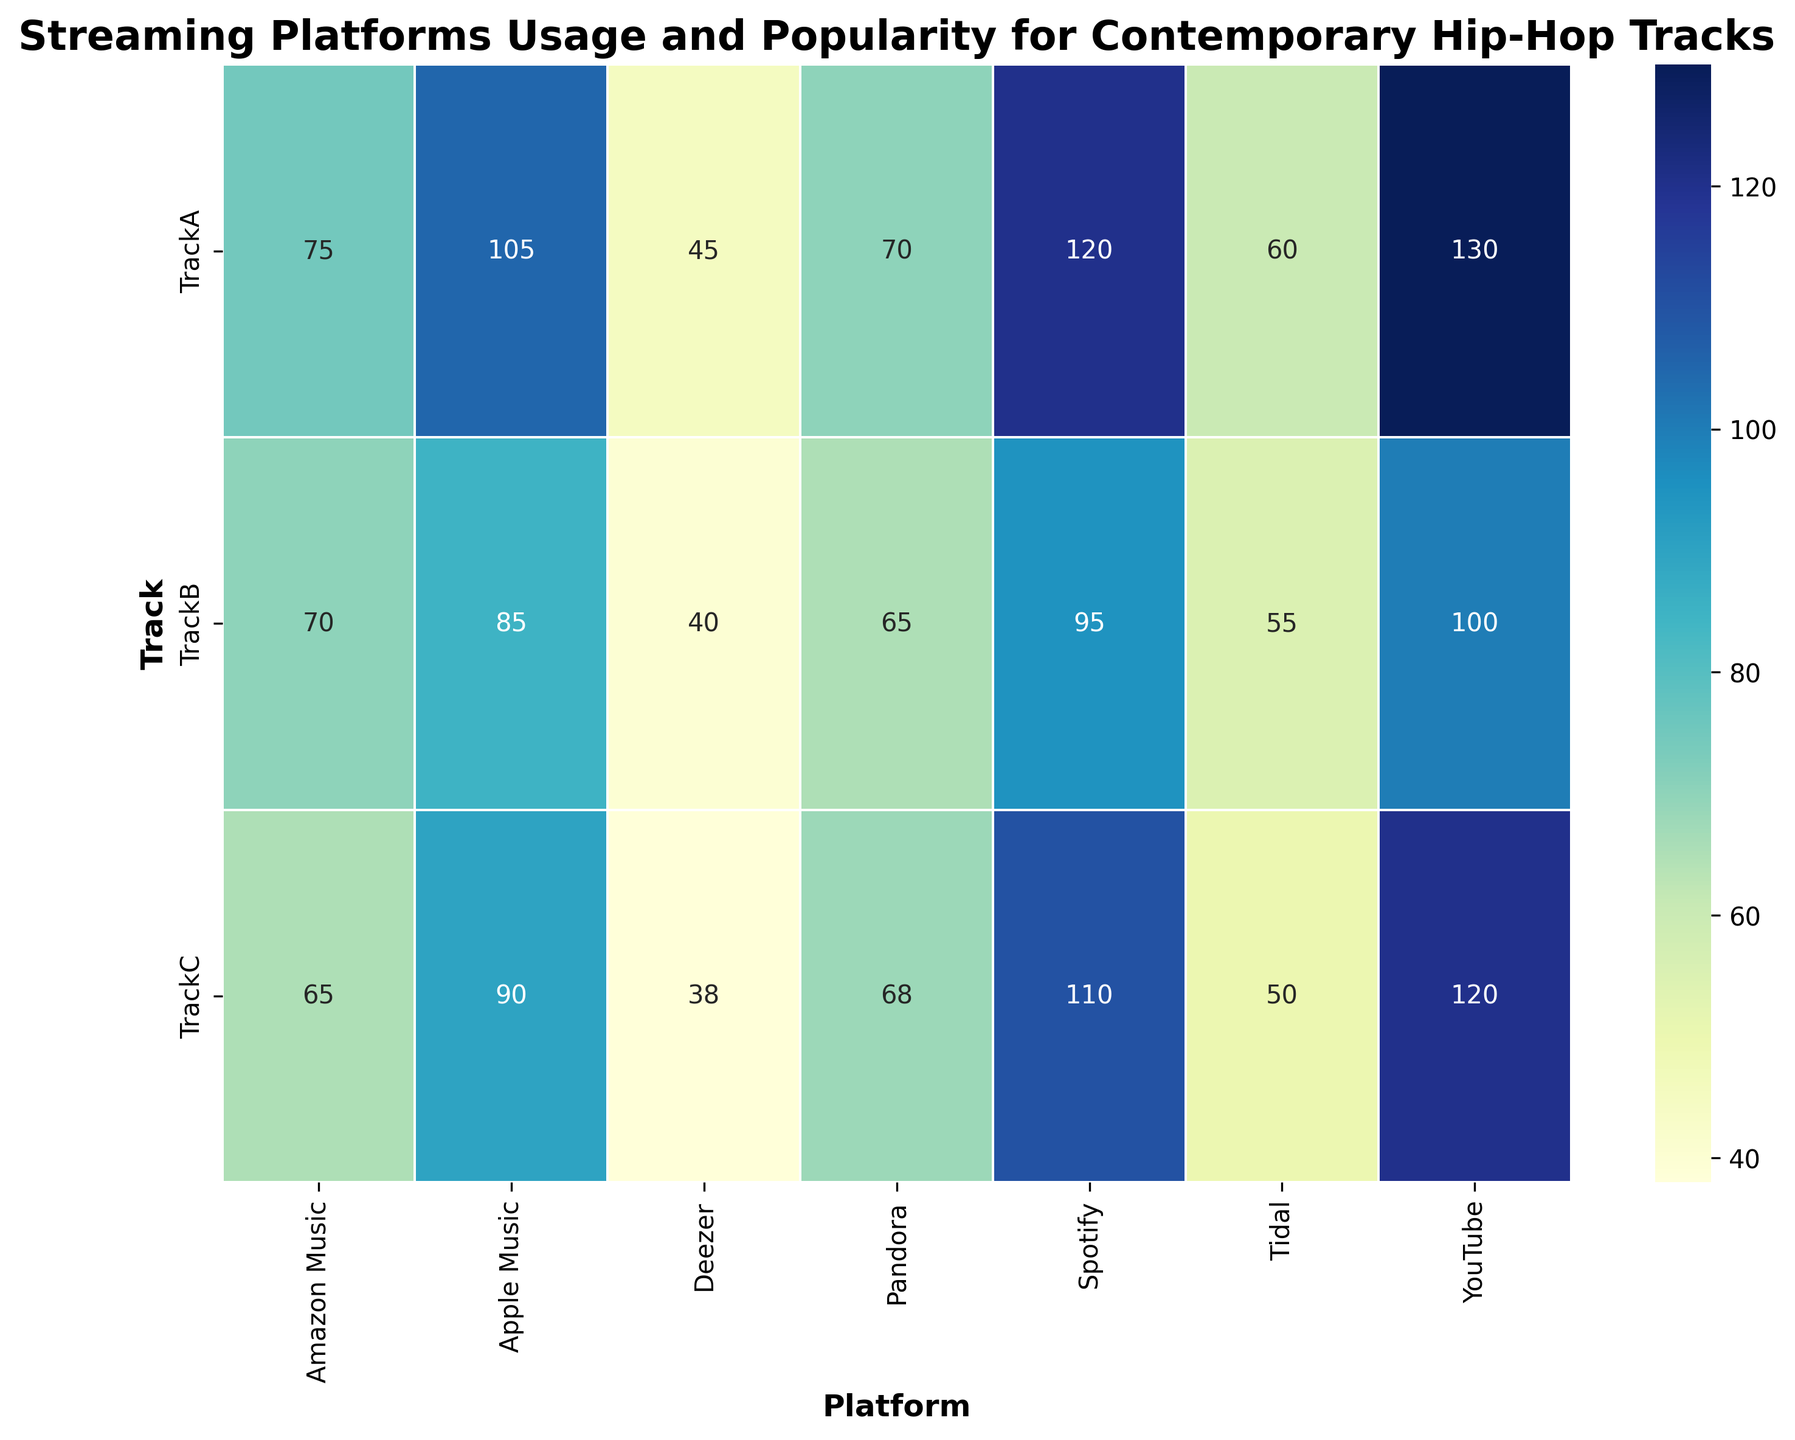What's the total number of streams for Track A across all platforms? Look at the values corresponding to Track A for each platform and sum them up: Spotify (120) + Apple Music (105) + YouTube (130) + Amazon Music (75) + Tidal (60) + Deezer (45) + Pandora (70) = 605
Answer: 605 Which platform has the highest number of streams for Track B? Compare the values for Track B across all platforms: Spotify (95), Apple Music (85), YouTube (100), Amazon Music (70), Tidal (55), Deezer (40), Pandora (65). YouTube has the highest streams.
Answer: YouTube Which track has the lowest number of streams on Tidal? Checking the streams on Tidal: Track A (60), Track B (55), Track C (50). Track C has the lowest number of streams.
Answer: Track C Which platform demonstrates the greatest variation in streaming numbers between the highest and lowest streamed tracks? Calculate the difference between the highest and lowest values for each platform: 
Spotify (120-95=25), Apple Music (105-85=20), YouTube (130-100=30), Amazon Music (75-65=10), Tidal (60-50=10), Deezer (45-38=7), Pandora (70-65=5). YouTube shows the highest variation, which is 130 - 100 = 30.
Answer: YouTube What's the average number of streams for Track C across all platforms? Sum the streams for Track C across all platforms and divide by the number of platforms: (Spotify 110 + Apple Music 90 + YouTube 120 + Amazon Music 65 + Tidal 50 + Deezer 38 + Pandora 68) / 7 = 77.29
Answer: 77.29 Which track has the highest overall number of streams across all platforms? Calculate the total streams for each track: 
Track A (Spotify 120 + Apple Music 105 + YouTube 130 + Amazon Music 75 + Tidal 60 + Deezer 45 + Pandora 70 = 605), 
Track B (Spotify 95 + Apple Music 85 + YouTube 100 + Amazon Music 70 + Tidal 55 + Deezer 40 + Pandora 65 = 510), 
Track C (Spotify 110 + Apple Music 90 + YouTube 120 + Amazon Music 65 + Tidal 50 + Deezer 38 + Pandora 68 = 541). Track A has the highest total streams.
Answer: Track A What’s the difference in the total streams between Spotify and YouTube for all tracks combined? Sum the streams for all tracks on both Spotify and YouTube, then find the difference: 
Spotify total: (120 + 95 + 110 = 325), 
YouTube total: (130 + 100 + 120 = 350). Difference = 350 - 325 = 25.
Answer: 25 